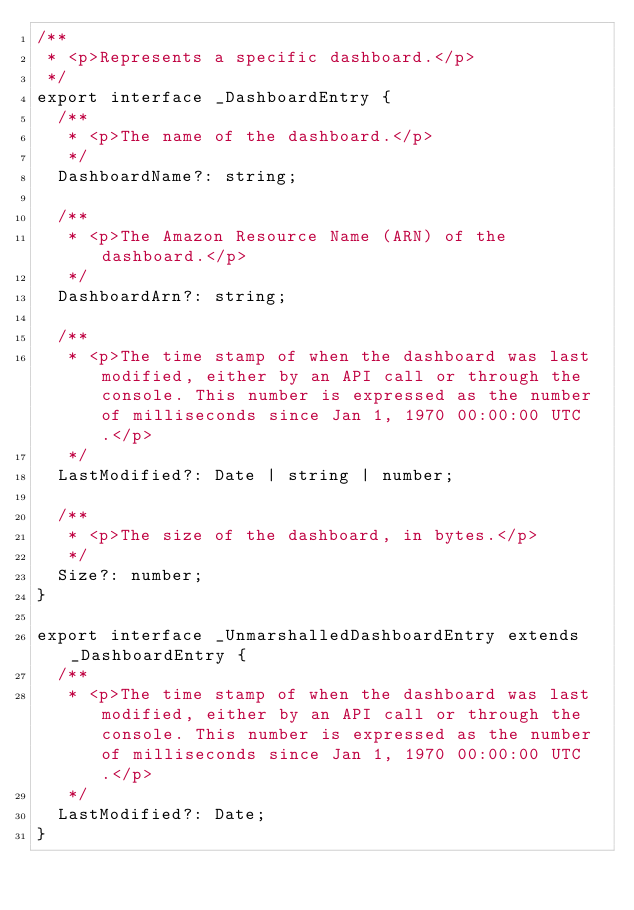<code> <loc_0><loc_0><loc_500><loc_500><_TypeScript_>/**
 * <p>Represents a specific dashboard.</p>
 */
export interface _DashboardEntry {
  /**
   * <p>The name of the dashboard.</p>
   */
  DashboardName?: string;

  /**
   * <p>The Amazon Resource Name (ARN) of the dashboard.</p>
   */
  DashboardArn?: string;

  /**
   * <p>The time stamp of when the dashboard was last modified, either by an API call or through the console. This number is expressed as the number of milliseconds since Jan 1, 1970 00:00:00 UTC.</p>
   */
  LastModified?: Date | string | number;

  /**
   * <p>The size of the dashboard, in bytes.</p>
   */
  Size?: number;
}

export interface _UnmarshalledDashboardEntry extends _DashboardEntry {
  /**
   * <p>The time stamp of when the dashboard was last modified, either by an API call or through the console. This number is expressed as the number of milliseconds since Jan 1, 1970 00:00:00 UTC.</p>
   */
  LastModified?: Date;
}
</code> 